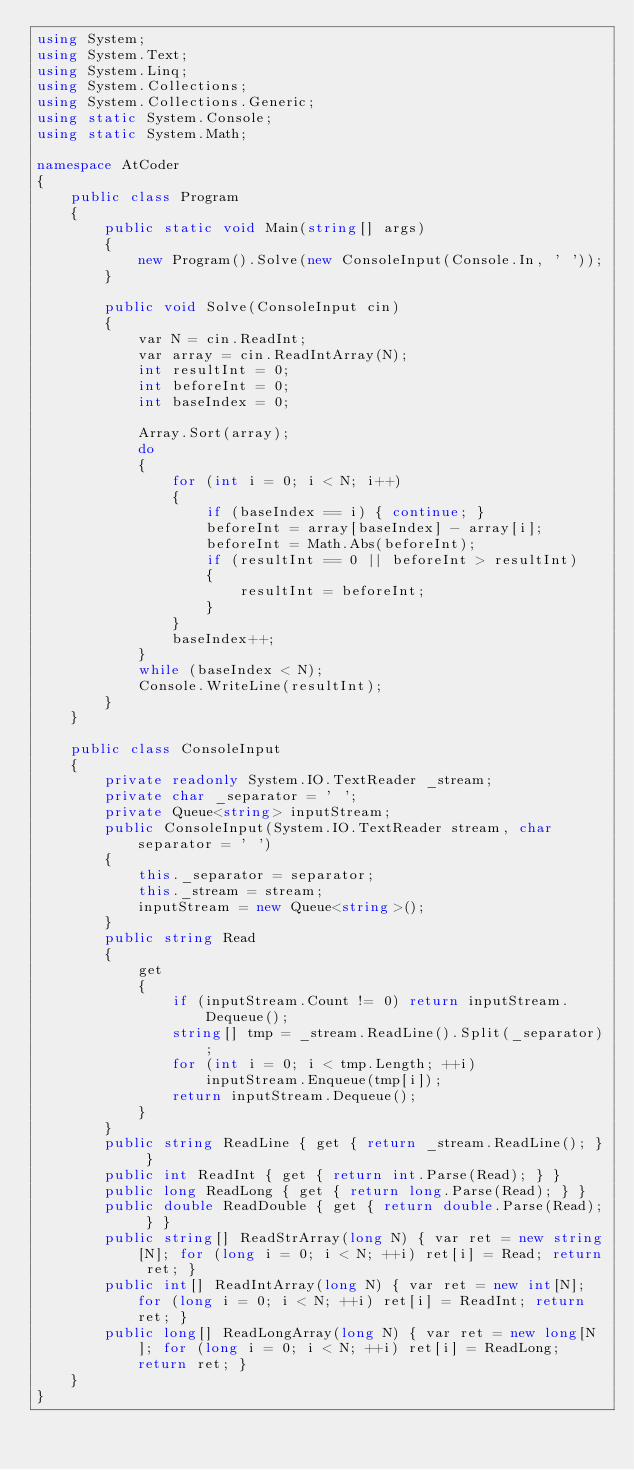Convert code to text. <code><loc_0><loc_0><loc_500><loc_500><_C#_>using System;
using System.Text;
using System.Linq;
using System.Collections;
using System.Collections.Generic;
using static System.Console;
using static System.Math;

namespace AtCoder
{
    public class Program
    {
        public static void Main(string[] args)
        {
            new Program().Solve(new ConsoleInput(Console.In, ' '));
        }

        public void Solve(ConsoleInput cin)
        {
            var N = cin.ReadInt;
            var array = cin.ReadIntArray(N);
            int resultInt = 0;
            int beforeInt = 0;
            int baseIndex = 0;

            Array.Sort(array);
            do
            {
                for (int i = 0; i < N; i++)
                {
                    if (baseIndex == i) { continue; }
                    beforeInt = array[baseIndex] - array[i];
                    beforeInt = Math.Abs(beforeInt);
                    if (resultInt == 0 || beforeInt > resultInt)
                    {
                        resultInt = beforeInt;
                    }
                }
                baseIndex++;
            }
            while (baseIndex < N);
            Console.WriteLine(resultInt);
        }
    }

    public class ConsoleInput
    {
        private readonly System.IO.TextReader _stream;
        private char _separator = ' ';
        private Queue<string> inputStream;
        public ConsoleInput(System.IO.TextReader stream, char separator = ' ')
        {
            this._separator = separator;
            this._stream = stream;
            inputStream = new Queue<string>();
        }
        public string Read
        {
            get
            {
                if (inputStream.Count != 0) return inputStream.Dequeue();
                string[] tmp = _stream.ReadLine().Split(_separator);
                for (int i = 0; i < tmp.Length; ++i)
                    inputStream.Enqueue(tmp[i]);
                return inputStream.Dequeue();
            }
        }
        public string ReadLine { get { return _stream.ReadLine(); } }
        public int ReadInt { get { return int.Parse(Read); } }
        public long ReadLong { get { return long.Parse(Read); } }
        public double ReadDouble { get { return double.Parse(Read); } }
        public string[] ReadStrArray(long N) { var ret = new string[N]; for (long i = 0; i < N; ++i) ret[i] = Read; return ret; }
        public int[] ReadIntArray(long N) { var ret = new int[N]; for (long i = 0; i < N; ++i) ret[i] = ReadInt; return ret; }
        public long[] ReadLongArray(long N) { var ret = new long[N]; for (long i = 0; i < N; ++i) ret[i] = ReadLong; return ret; }
    }
}</code> 